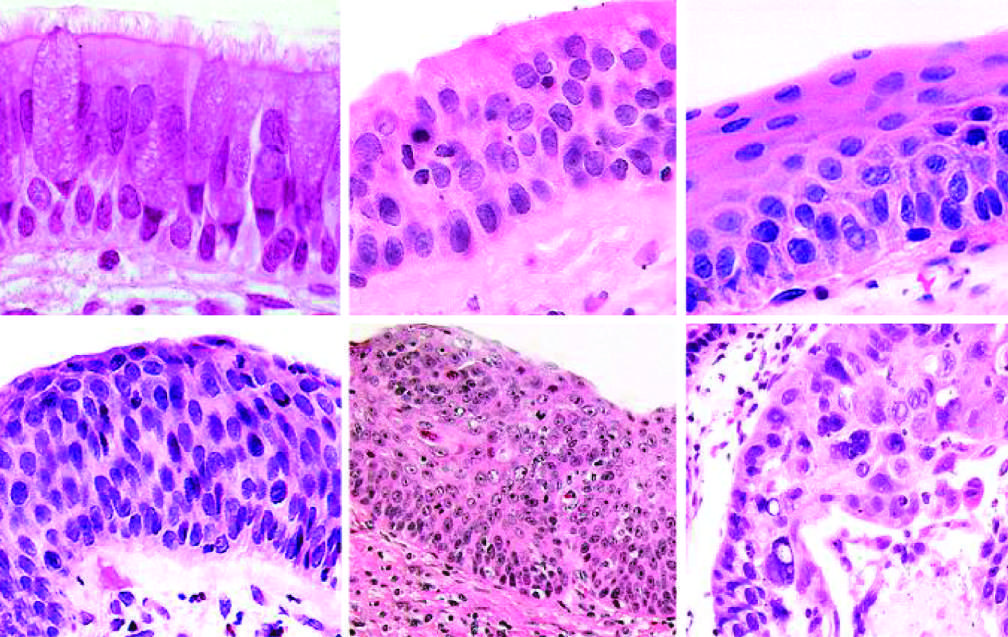what are the cytologic features of cis similar to?
Answer the question using a single word or phrase. Those in frank carcinoma 